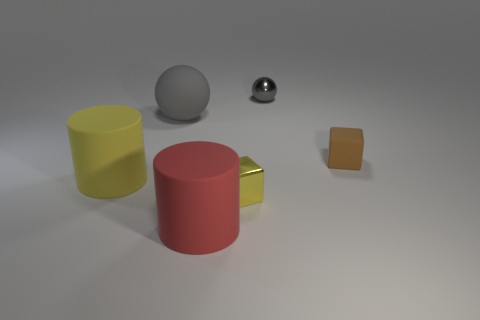Subtract all brown cubes. How many cubes are left? 1 Add 5 big gray matte spheres. How many big gray matte spheres exist? 6 Add 3 large blue metallic spheres. How many objects exist? 9 Subtract 0 blue balls. How many objects are left? 6 Subtract all balls. How many objects are left? 4 Subtract 2 cylinders. How many cylinders are left? 0 Subtract all purple cylinders. Subtract all green balls. How many cylinders are left? 2 Subtract all gray spheres. How many gray cylinders are left? 0 Subtract all red matte cylinders. Subtract all large balls. How many objects are left? 4 Add 1 yellow shiny cubes. How many yellow shiny cubes are left? 2 